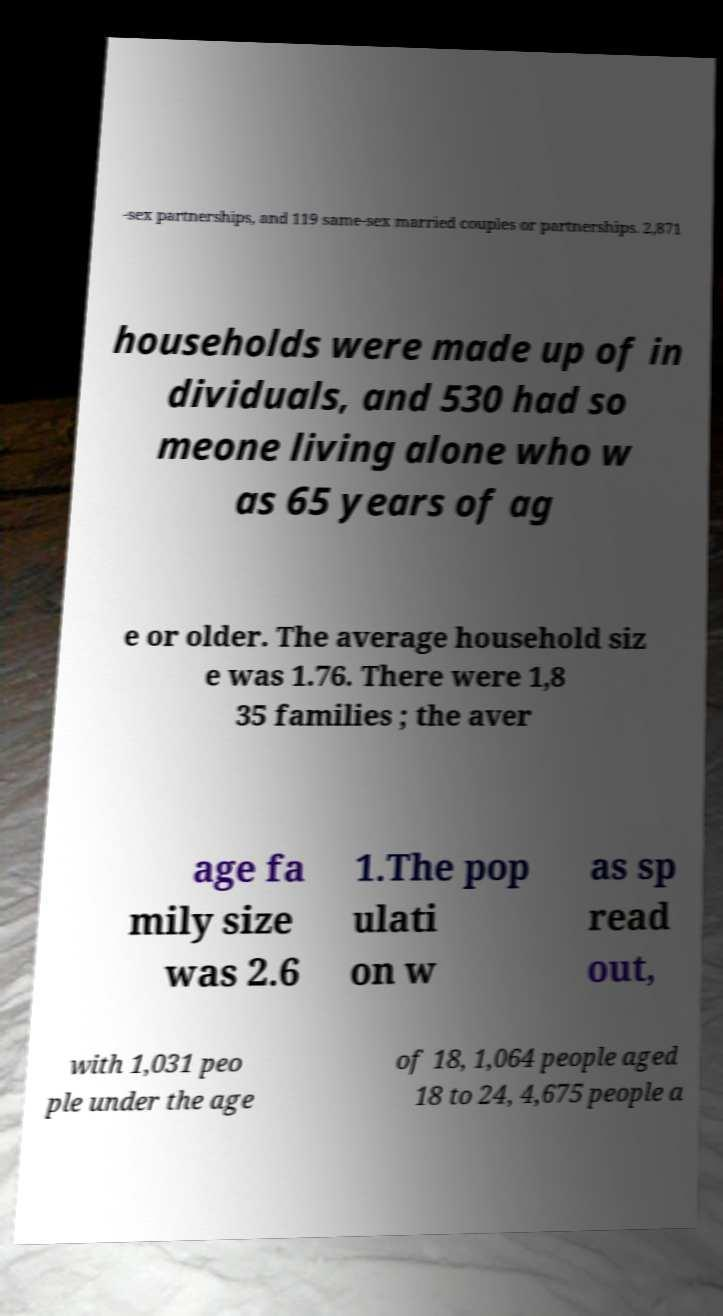Can you accurately transcribe the text from the provided image for me? -sex partnerships, and 119 same-sex married couples or partnerships. 2,871 households were made up of in dividuals, and 530 had so meone living alone who w as 65 years of ag e or older. The average household siz e was 1.76. There were 1,8 35 families ; the aver age fa mily size was 2.6 1.The pop ulati on w as sp read out, with 1,031 peo ple under the age of 18, 1,064 people aged 18 to 24, 4,675 people a 